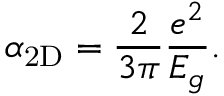<formula> <loc_0><loc_0><loc_500><loc_500>\alpha _ { 2 D } = \frac { 2 } { 3 \pi } \frac { e ^ { 2 } } { E _ { g } } .</formula> 